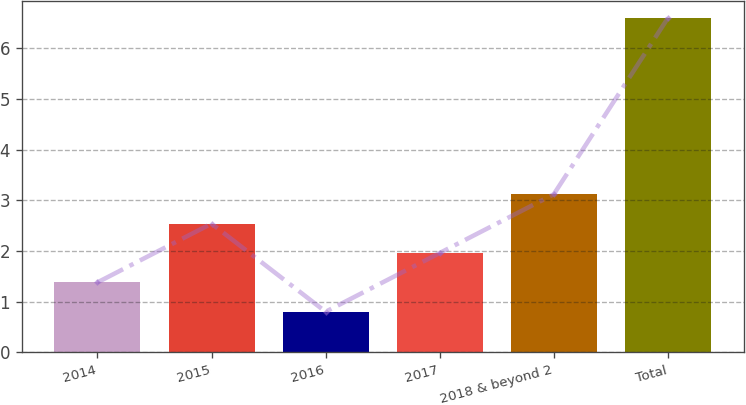Convert chart. <chart><loc_0><loc_0><loc_500><loc_500><bar_chart><fcel>2014<fcel>2015<fcel>2016<fcel>2017<fcel>2018 & beyond 2<fcel>Total<nl><fcel>1.38<fcel>2.54<fcel>0.8<fcel>1.96<fcel>3.12<fcel>6.6<nl></chart> 